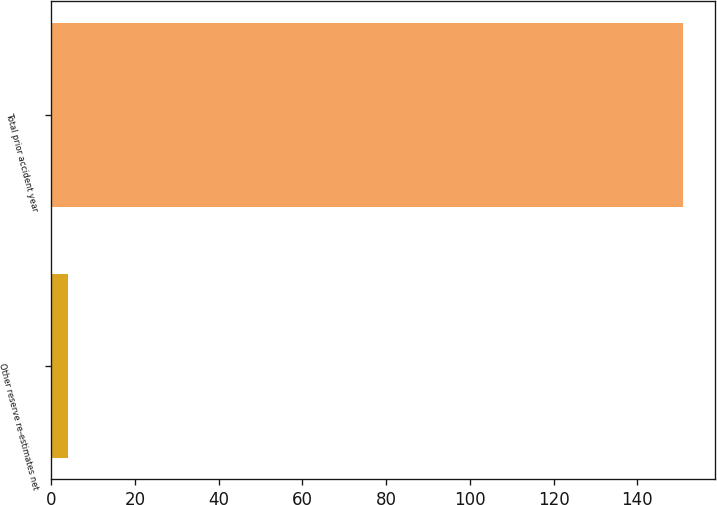Convert chart. <chart><loc_0><loc_0><loc_500><loc_500><bar_chart><fcel>Other reserve re-estimates net<fcel>Total prior accident year<nl><fcel>4<fcel>151<nl></chart> 